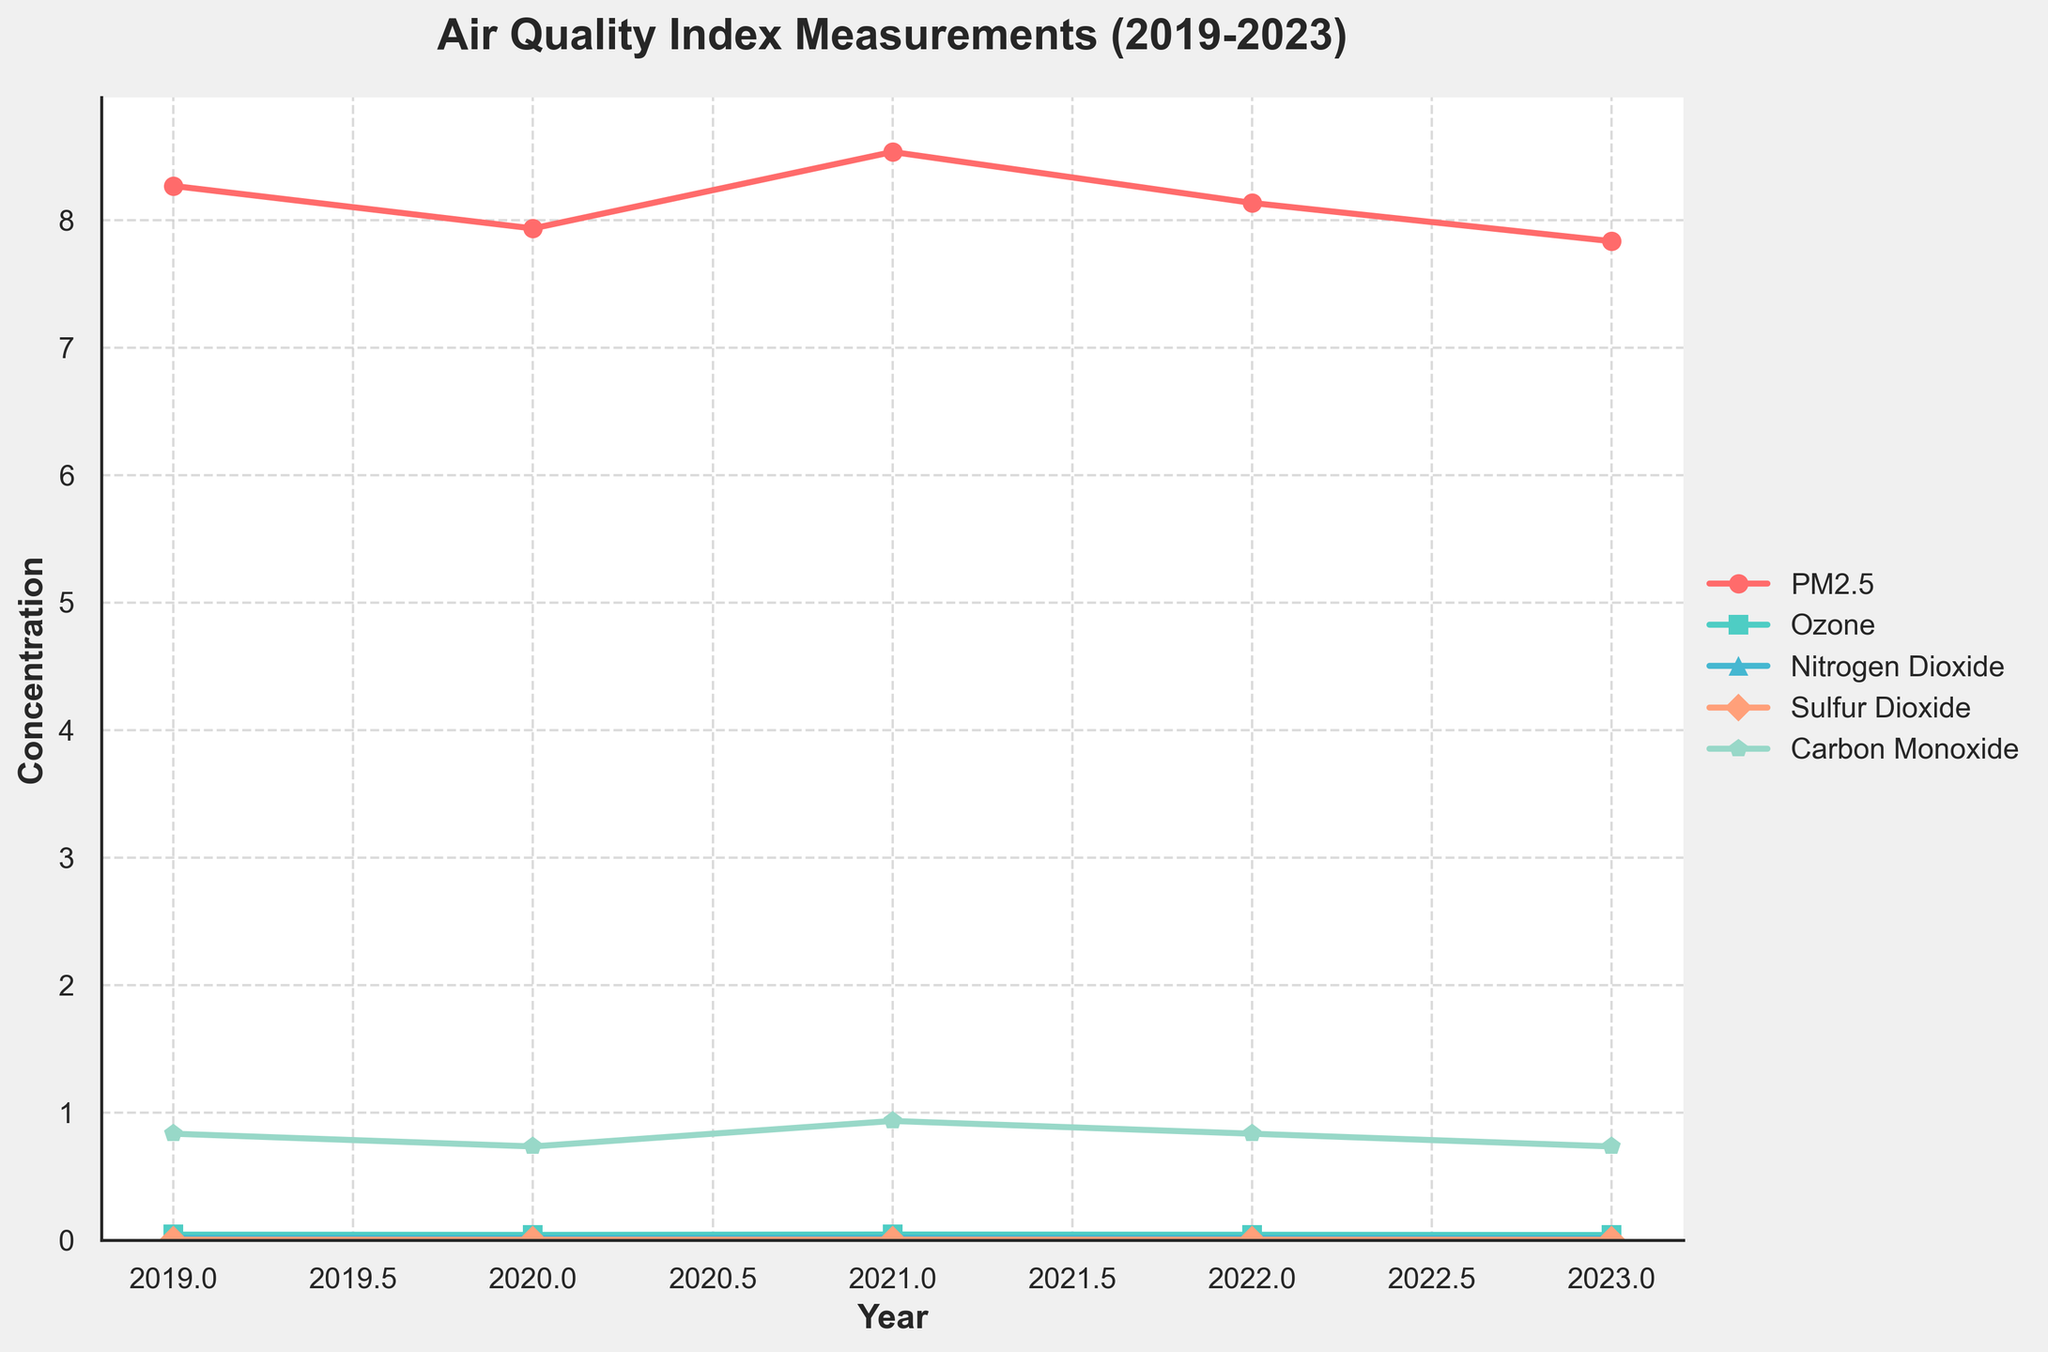How has the average concentration of PM2.5 changed from 2019 to 2023? The figure shows the average concentration values of PM2.5 for each year. By examining the line for PM2.5, we can see it started at around 8.27 in 2019 and dropped to 7.83 in 2023, indicating a decrease over time.
Answer: decreased Which pollutant had the highest concentration in 2021? By comparing the peak points in the 2021 section for each pollutant, PM2.5 had the highest value (around 8.53).
Answer: PM2.5 In which year was the concentration of Carbon Monoxide the lowest? By looking at the lines for Carbon Monoxide and their lowest points, 2023 had the lowest concentration (~0.73).
Answer: 2023 Compare the trends of Ozone and Nitrogen Dioxide from 2021 to 2023. Which one decreased more? From the graph, Ozone decreased from around 0.042 in 2021 to 0.039 in 2023, and Nitrogen Dioxide decreased from roughly 0.015 to 0.013. Therefore, Nitrogen Dioxide saw a bigger decrease.
Answer: Nitrogen Dioxide What was the average concentration of Sulfur Dioxide over the entire period? Looking at the 5 points for Sulfur Dioxide (2019: 0.002, 2020: 0.002, 2021: 0.002, 2022: 0.002, 2023: 0.002), their sum is 0.01. Dividing by 5 gives the average of 0.002.
Answer: 0.002 What is the difference in concentration of Carbon Monoxide between 2020 and 2021? From the graph, Carbon Monoxide in 2020 is 0.83 and in 2021 it is 0.90. The difference is 0.90 - 0.83 = 0.07.
Answer: 0.07 During which years did PM2.5 exceed 8.0? Examining each point for PM2.5, it exceeded 8.0 in 2021 and in most records of 2019, 2022, and during certain periods of 2020.
Answer: 2019, 2020, 2021, 2022 Which pollutant had the least variability in its concentration over the years? By comparing the fluctuations in the lines for each pollutant, Sulfur Dioxide has the most constant line, indicating the least variability.
Answer: Sulfur Dioxide 